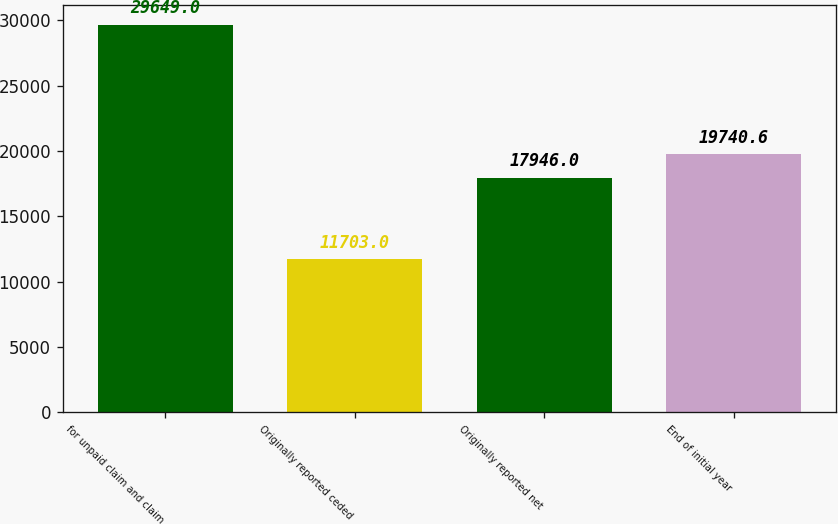<chart> <loc_0><loc_0><loc_500><loc_500><bar_chart><fcel>for unpaid claim and claim<fcel>Originally reported ceded<fcel>Originally reported net<fcel>End of initial year<nl><fcel>29649<fcel>11703<fcel>17946<fcel>19740.6<nl></chart> 